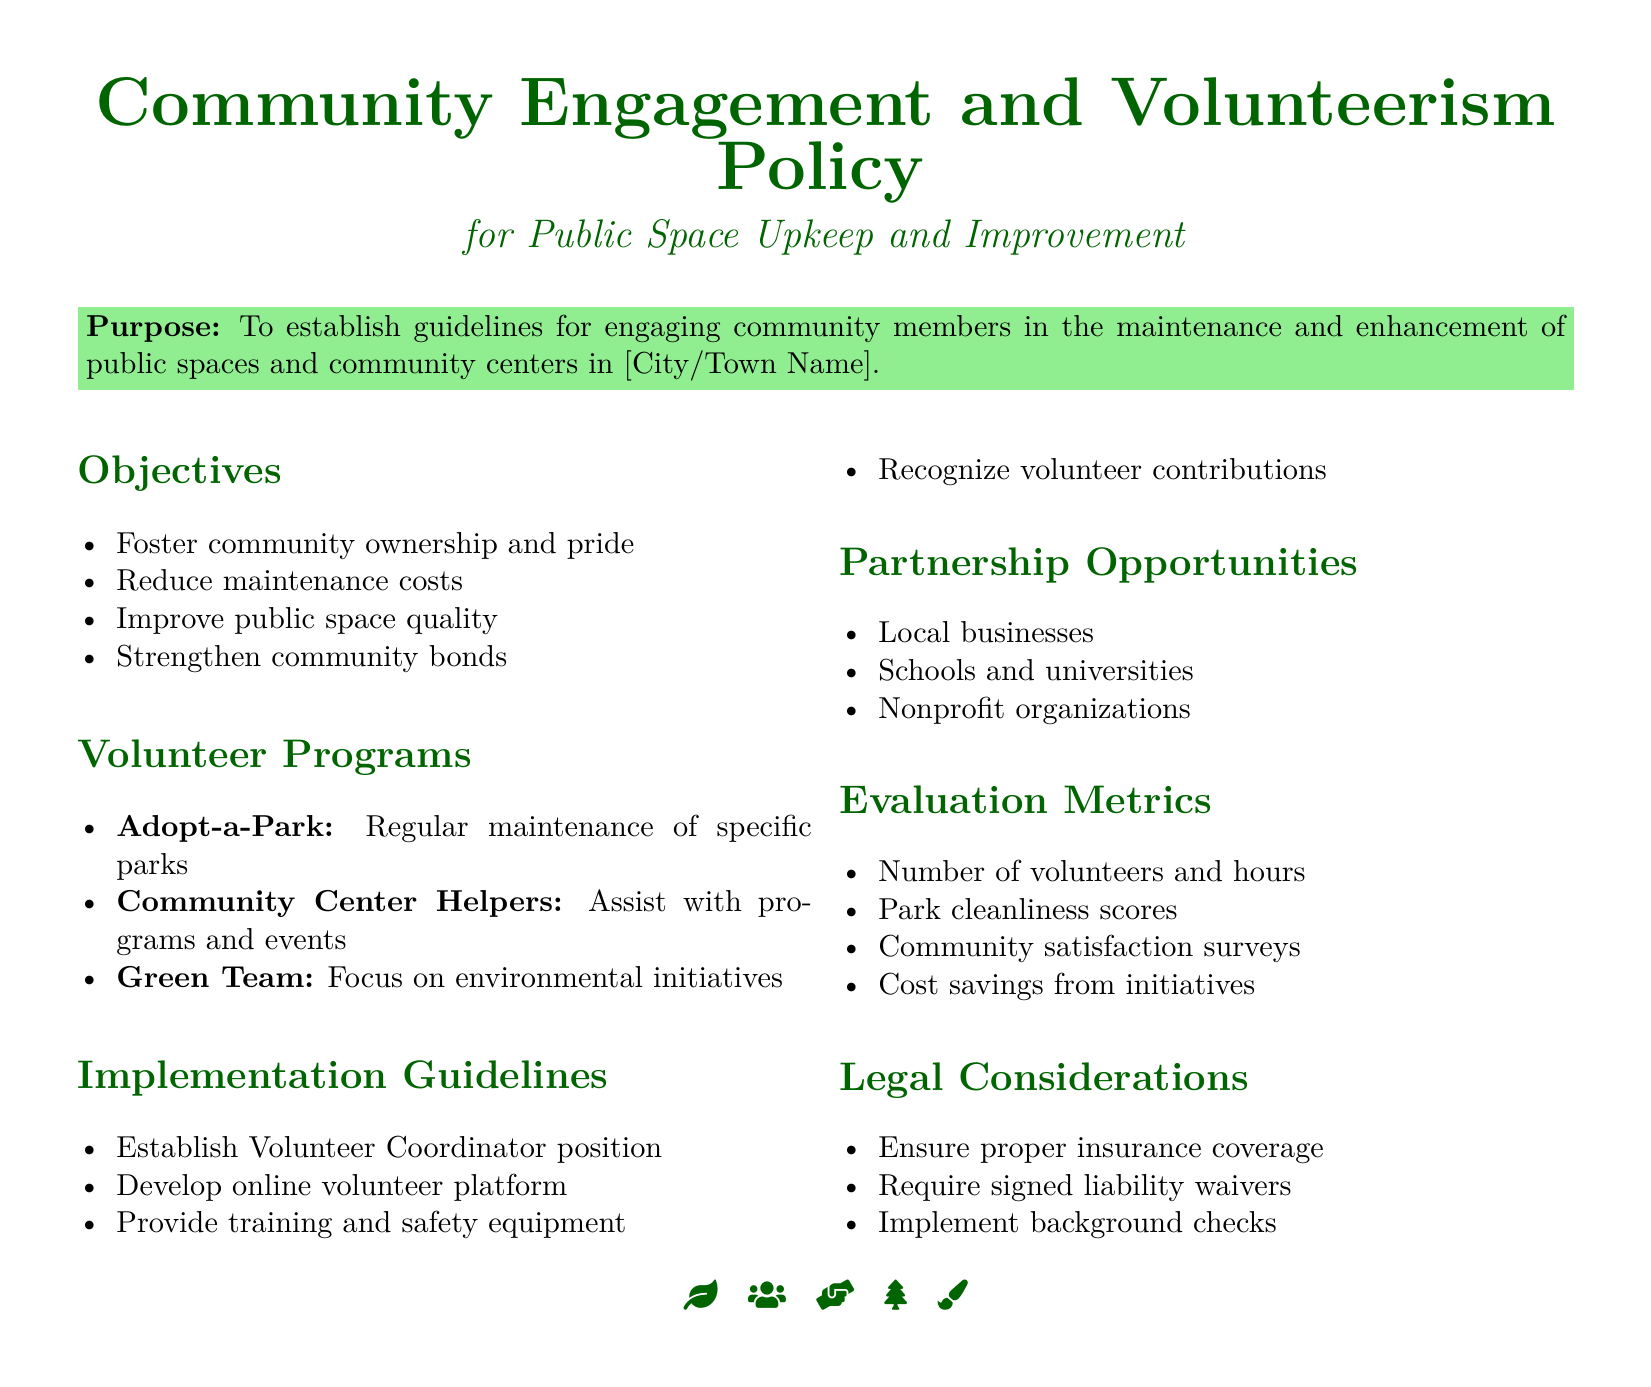What is the purpose of the policy? The purpose is defined in the document and states the guidelines for community engagement in public space maintenance.
Answer: To establish guidelines for engaging community members in the maintenance and enhancement of public spaces and community centers in [City/Town Name] What is one objective of the policy? The document lists multiple objectives, seeking to improve community aspects related to public spaces.
Answer: Foster community ownership and pride How many volunteer programs are mentioned? The document lists specific volunteer programs under the Volunteer Programs section.
Answer: Three What is the title of the volunteer coordinator position? The document specifies this role in the Implementation Guidelines section.
Answer: Volunteer Coordinator Which group assists with community center programs? The document names groups responsible for various tasks under the Volunteer Programs section.
Answer: Community Center Helpers What is a metric for evaluating volunteer efforts? The Evaluation Metrics section of the document includes various indicators of success for volunteer programs.
Answer: Number of volunteers and hours Who can be a partner in this policy initiative? The document lists potential partnership opportunities for implementing the policy.
Answer: Local businesses What is required before volunteers can participate? The Legal Considerations section specifies essential protocols to ensure safety and legality in volunteer involvement.
Answer: Signed liability waivers 